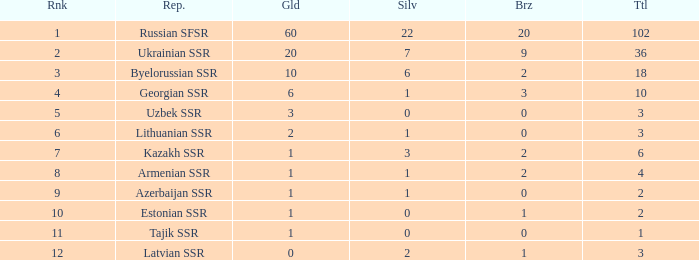What is the sum of bronzes for teams with more than 2 gold, ranked under 3, and less than 22 silver? 9.0. 